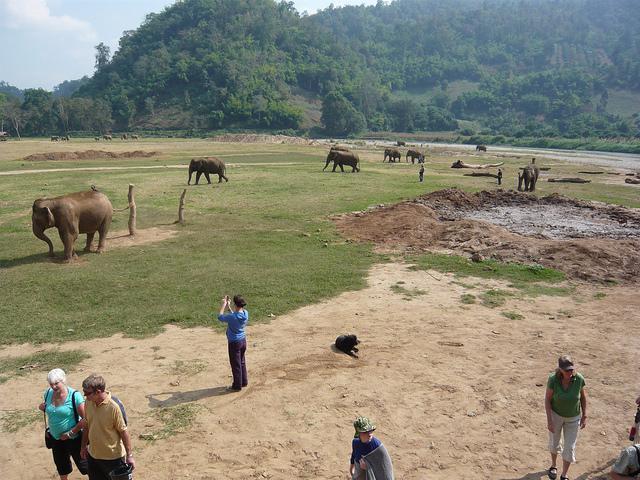The person holding the camera is wearing what color shirt?
From the following set of four choices, select the accurate answer to respond to the question.
Options: Orange, yellow, blue, red. Blue. 